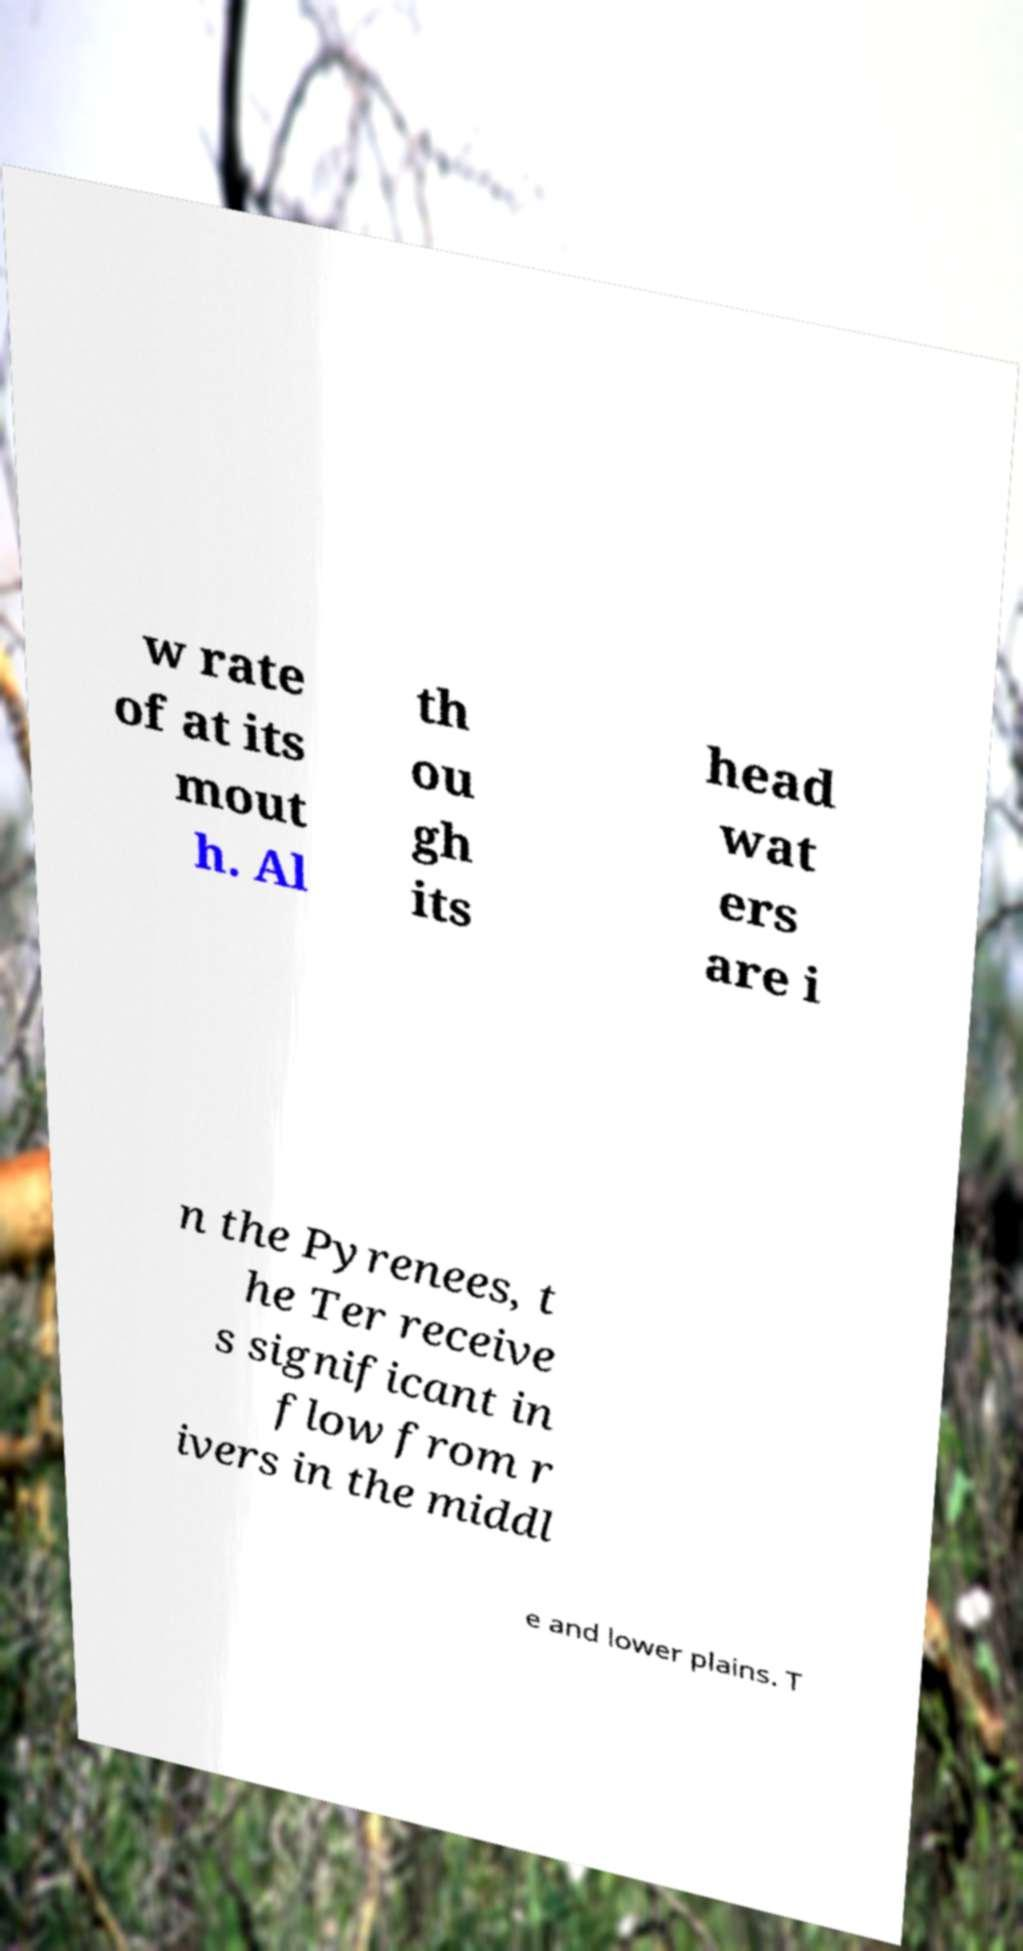What messages or text are displayed in this image? I need them in a readable, typed format. w rate of at its mout h. Al th ou gh its head wat ers are i n the Pyrenees, t he Ter receive s significant in flow from r ivers in the middl e and lower plains. T 